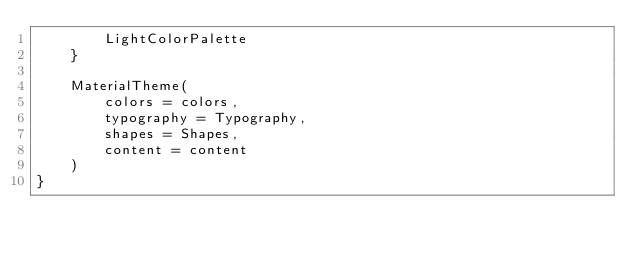<code> <loc_0><loc_0><loc_500><loc_500><_Kotlin_>        LightColorPalette
    }

    MaterialTheme(
        colors = colors,
        typography = Typography,
        shapes = Shapes,
        content = content
    )
}</code> 